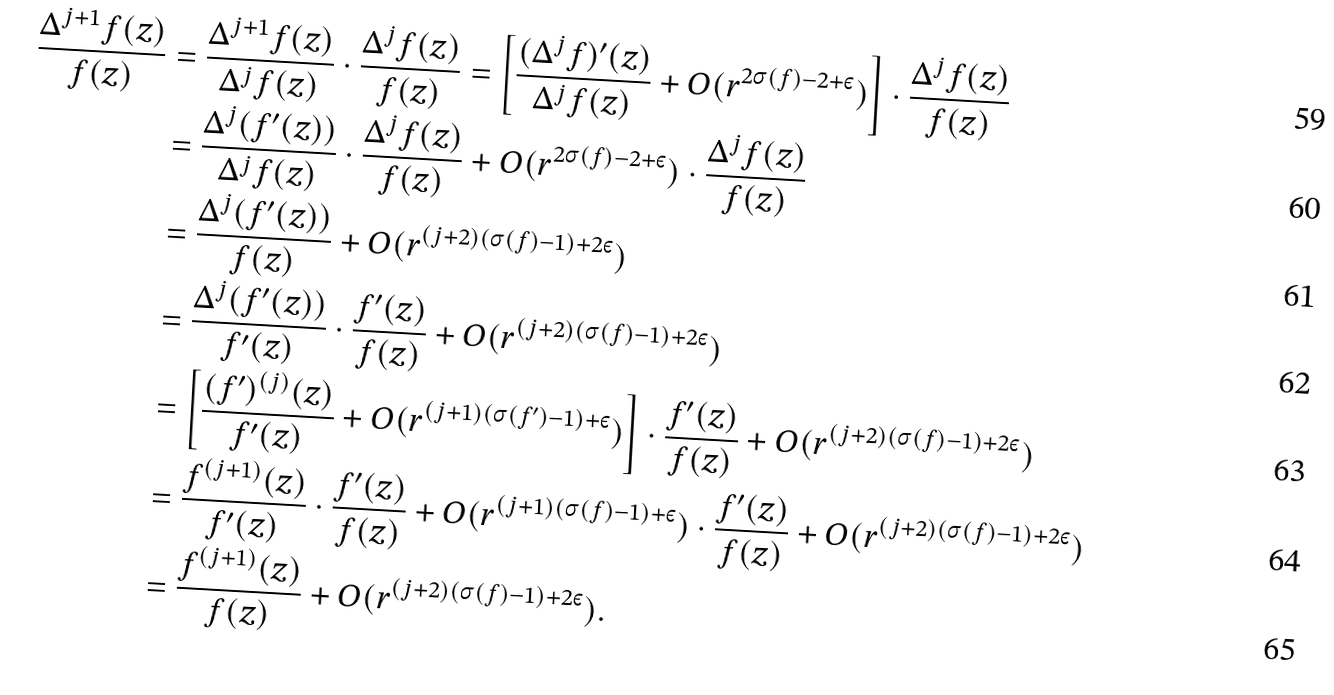Convert formula to latex. <formula><loc_0><loc_0><loc_500><loc_500>\frac { \Delta ^ { j + 1 } f ( z ) } { f ( z ) } & = \frac { \Delta ^ { j + 1 } f ( z ) } { \Delta ^ { j } f ( z ) } \cdot \frac { \Delta ^ { j } f ( z ) } { f ( z ) } = \left [ \frac { ( \Delta ^ { j } f ) ^ { \prime } ( z ) } { \Delta ^ { j } f ( z ) } + O ( r ^ { 2 \sigma ( f ) - 2 + \varepsilon } ) \right ] \cdot \frac { \Delta ^ { j } f ( z ) } { f ( z ) } \\ & = \frac { \Delta ^ { j } ( f ^ { \prime } ( z ) ) } { \Delta ^ { j } f ( z ) } \cdot \frac { \Delta ^ { j } f ( z ) } { f ( z ) } + O ( r ^ { 2 \sigma ( f ) - 2 + \varepsilon } ) \cdot \frac { \Delta ^ { j } f ( z ) } { f ( z ) } \\ & = \frac { \Delta ^ { j } ( f ^ { \prime } ( z ) ) } { f ( z ) } + O ( r ^ { ( j + 2 ) ( \sigma ( f ) - 1 ) + 2 \varepsilon } ) \\ & = \frac { \Delta ^ { j } ( f ^ { \prime } ( z ) ) } { f ^ { \prime } ( z ) } \cdot \frac { f ^ { \prime } ( z ) } { f ( z ) } + O ( r ^ { ( j + 2 ) ( \sigma ( f ) - 1 ) + 2 \varepsilon } ) \\ & = \left [ \frac { ( f ^ { \prime } ) ^ { ( j ) } ( z ) } { f ^ { \prime } ( z ) } + O ( r ^ { ( j + 1 ) ( \sigma ( f ^ { \prime } ) - 1 ) + \varepsilon } ) \right ] \cdot \frac { f ^ { \prime } ( z ) } { f ( z ) } + O ( r ^ { ( j + 2 ) ( \sigma ( f ) - 1 ) + 2 \varepsilon } ) \\ & = \frac { f ^ { ( j + 1 ) } ( z ) } { f ^ { \prime } ( z ) } \cdot \frac { f ^ { \prime } ( z ) } { f ( z ) } + O ( r ^ { ( j + 1 ) ( \sigma ( f ) - 1 ) + \varepsilon } ) \cdot \frac { f ^ { \prime } ( z ) } { f ( z ) } + O ( r ^ { ( j + 2 ) ( \sigma ( f ) - 1 ) + 2 \varepsilon } ) \\ & = \frac { f ^ { ( j + 1 ) } ( z ) } { f ( z ) } + O ( r ^ { ( j + 2 ) ( \sigma ( f ) - 1 ) + 2 \varepsilon } ) .</formula> 